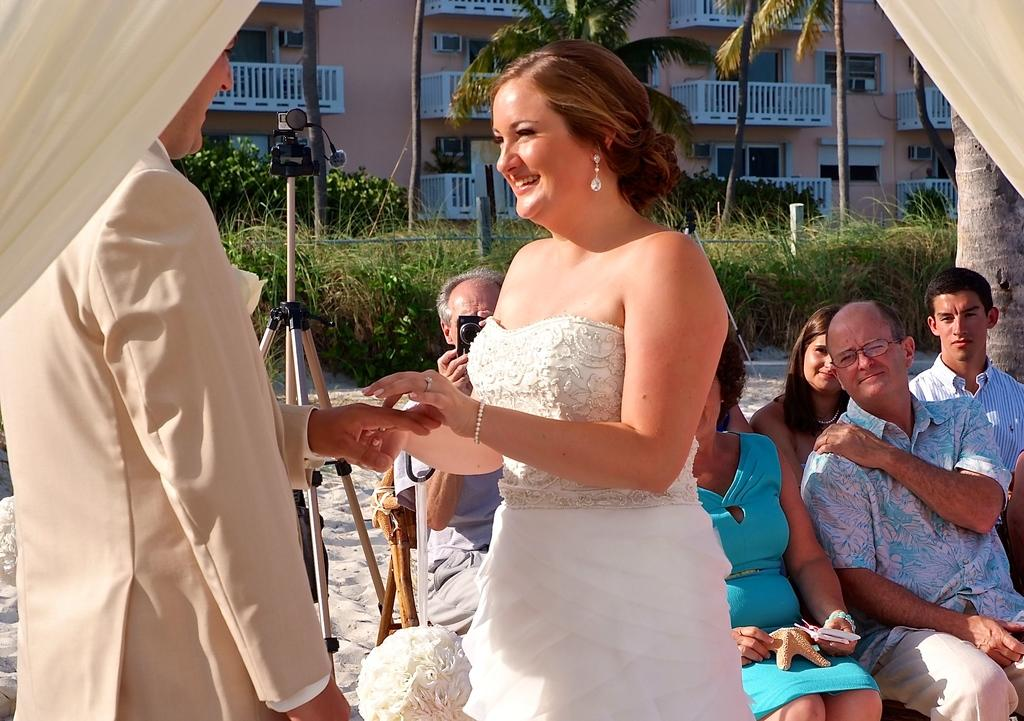What are the people in the image doing? The people in the sand are engaged in various activities, including one person holding a camera and taking a photo. What is the purpose of the camera on a stand? The camera on a stand is likely being used for professional photography or videography. What type of natural elements can be seen in the image? There are trees, plants, and sand visible in the image. What type of man-made structure is present in the image? There is a fence in the image. What type of trade is being conducted in the image? There is no indication of any trade being conducted in the image; it primarily features people in the sand and various photography equipment. Can you see the ocean in the image? No, the ocean is not visible in the image; it primarily features people in the sand and various photography equipment. 